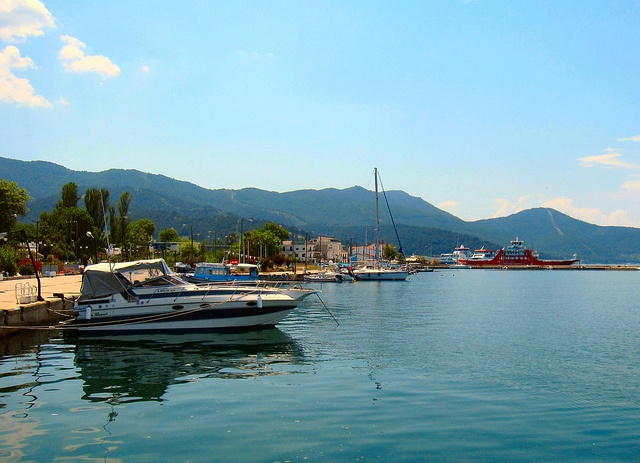Describe the objects in this image and their specific colors. I can see boat in ivory, black, gray, purple, and darkgray tones, boat in ivory, maroon, black, gray, and blue tones, boat in ivory, blue, black, and gray tones, boat in ivory, blue, black, darkblue, and gray tones, and boat in ivory, blue, gray, and beige tones in this image. 